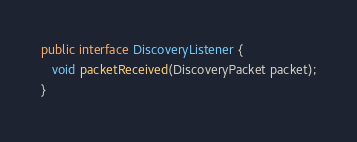Convert code to text. <code><loc_0><loc_0><loc_500><loc_500><_Java_>
public interface DiscoveryListener {
   void packetReceived(DiscoveryPacket packet);
}</code> 